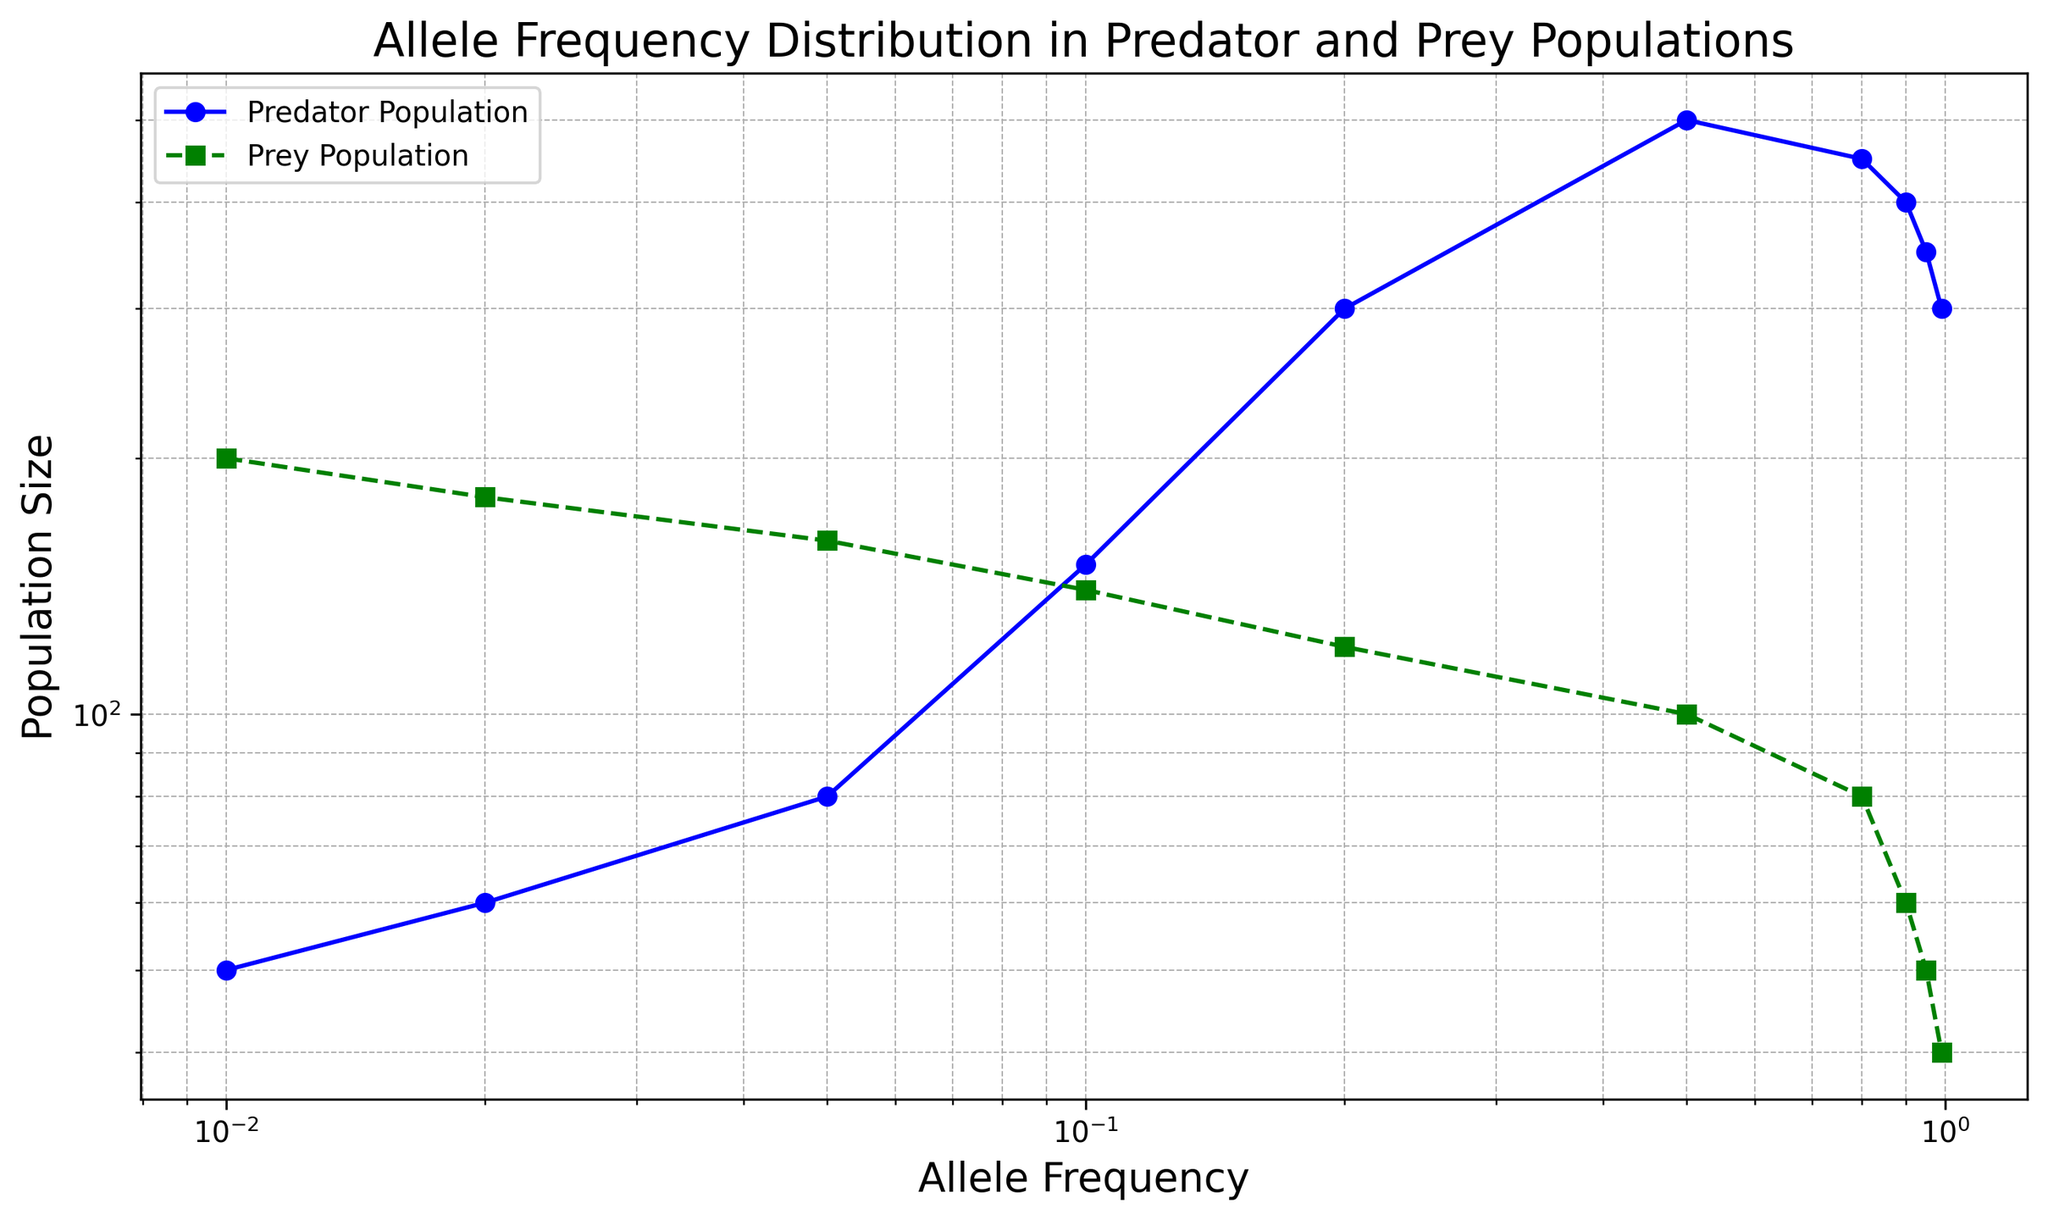What is the population size of predators at an allele frequency of 0.1? At the allele frequency of 0.1 on the x-axis, look at the corresponding value on the predator population curve (blue line).
Answer: 150 Which population has a higher size at an allele frequency of 0.8? At the allele frequency of 0.8 on the x-axis, compare the values of predator and prey populations. The blue line (predator) is higher than the green line (prey).
Answer: Predator What is the range of predator population sizes across all allele frequencies? The smallest predator population size is at an allele frequency of 0.01 (50), and the largest is at 0.5 (500). Subtract 50 from 500.
Answer: 450 What is the difference in prey population size between allele frequencies of 0.05 and 0.2? At allele frequency 0.05, the prey population is 160, and at 0.2, it is 120. Subtract 120 from 160.
Answer: 40 Which population size declines more steeply as allele frequency approaches 1.0? Observe the slopes of the predator (blue) and prey (green) curves as allele frequency increases from around 0.5 to 1.0. The prey population declines more steeply.
Answer: Prey What is the average prey population size for allele frequencies 0.2 and 0.8? The prey population sizes at 0.2 and 0.8 are 120 and 80, respectively. Add them (120 + 80 = 200) and divide by 2.
Answer: 100 How does the allelic frequency of 0.1 correlate with predator and prey populations? Look at the allele frequency of 0.1 and check the corresponding values for predator (150) and prey (140) populations.
Answer: Higher predator population Is there any allele frequency at which predator and prey populations are equal? Scan the graph to see if the blue and green lines intersect at any point.
Answer: No By what factor does the predator population increase when allele frequency goes from 0.01 to 0.5? The predator population at 0.01 is 50, at 0.5 is 500. Divide 500 by 50.
Answer: 10 What can be inferred about the relative population sizes at very high allele frequencies (close to 1)? As allele frequency approaches 1, observe that the predator population is consistently higher than the prey population.
Answer: Predators are higher 